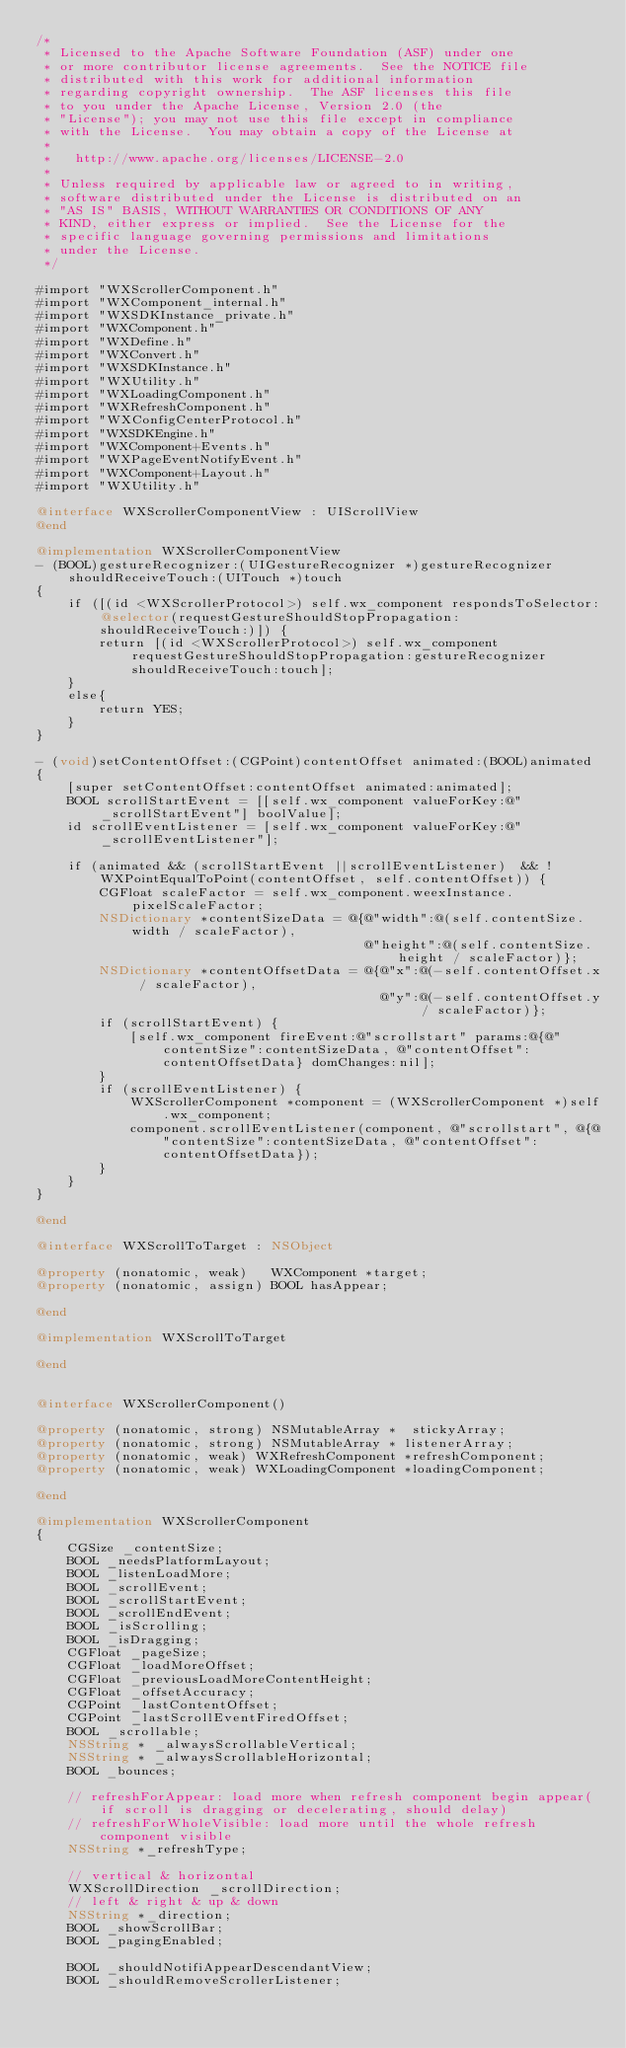Convert code to text. <code><loc_0><loc_0><loc_500><loc_500><_ObjectiveC_>/*
 * Licensed to the Apache Software Foundation (ASF) under one
 * or more contributor license agreements.  See the NOTICE file
 * distributed with this work for additional information
 * regarding copyright ownership.  The ASF licenses this file
 * to you under the Apache License, Version 2.0 (the
 * "License"); you may not use this file except in compliance
 * with the License.  You may obtain a copy of the License at
 *
 *   http://www.apache.org/licenses/LICENSE-2.0
 *
 * Unless required by applicable law or agreed to in writing,
 * software distributed under the License is distributed on an
 * "AS IS" BASIS, WITHOUT WARRANTIES OR CONDITIONS OF ANY
 * KIND, either express or implied.  See the License for the
 * specific language governing permissions and limitations
 * under the License.
 */

#import "WXScrollerComponent.h"
#import "WXComponent_internal.h"
#import "WXSDKInstance_private.h"
#import "WXComponent.h"
#import "WXDefine.h"
#import "WXConvert.h"
#import "WXSDKInstance.h"
#import "WXUtility.h"
#import "WXLoadingComponent.h"
#import "WXRefreshComponent.h"
#import "WXConfigCenterProtocol.h"
#import "WXSDKEngine.h"
#import "WXComponent+Events.h"
#import "WXPageEventNotifyEvent.h"
#import "WXComponent+Layout.h"
#import "WXUtility.h"

@interface WXScrollerComponentView : UIScrollView
@end

@implementation WXScrollerComponentView
- (BOOL)gestureRecognizer:(UIGestureRecognizer *)gestureRecognizer shouldReceiveTouch:(UITouch *)touch
{
    if ([(id <WXScrollerProtocol>) self.wx_component respondsToSelector:@selector(requestGestureShouldStopPropagation:shouldReceiveTouch:)]) {
        return [(id <WXScrollerProtocol>) self.wx_component requestGestureShouldStopPropagation:gestureRecognizer shouldReceiveTouch:touch];
    }
    else{
        return YES;
    }
}

- (void)setContentOffset:(CGPoint)contentOffset animated:(BOOL)animated
{
    [super setContentOffset:contentOffset animated:animated];
    BOOL scrollStartEvent = [[self.wx_component valueForKey:@"_scrollStartEvent"] boolValue];
    id scrollEventListener = [self.wx_component valueForKey:@"_scrollEventListener"];
    
    if (animated && (scrollStartEvent ||scrollEventListener)  && !WXPointEqualToPoint(contentOffset, self.contentOffset)) {
        CGFloat scaleFactor = self.wx_component.weexInstance.pixelScaleFactor;
        NSDictionary *contentSizeData = @{@"width":@(self.contentSize.width / scaleFactor),
                                          @"height":@(self.contentSize.height / scaleFactor)};
        NSDictionary *contentOffsetData = @{@"x":@(-self.contentOffset.x / scaleFactor),
                                            @"y":@(-self.contentOffset.y / scaleFactor)};
        if (scrollStartEvent) {
            [self.wx_component fireEvent:@"scrollstart" params:@{@"contentSize":contentSizeData, @"contentOffset":contentOffsetData} domChanges:nil];
        }
        if (scrollEventListener) {
            WXScrollerComponent *component = (WXScrollerComponent *)self.wx_component;
            component.scrollEventListener(component, @"scrollstart", @{@"contentSize":contentSizeData, @"contentOffset":contentOffsetData});
        }
    }
}

@end

@interface WXScrollToTarget : NSObject

@property (nonatomic, weak)   WXComponent *target;
@property (nonatomic, assign) BOOL hasAppear;

@end

@implementation WXScrollToTarget

@end


@interface WXScrollerComponent()

@property (nonatomic, strong) NSMutableArray *  stickyArray;
@property (nonatomic, strong) NSMutableArray * listenerArray;
@property (nonatomic, weak) WXRefreshComponent *refreshComponent;
@property (nonatomic, weak) WXLoadingComponent *loadingComponent;

@end

@implementation WXScrollerComponent
{
    CGSize _contentSize;
    BOOL _needsPlatformLayout;
    BOOL _listenLoadMore;
    BOOL _scrollEvent;
    BOOL _scrollStartEvent;
    BOOL _scrollEndEvent;
    BOOL _isScrolling;
    BOOL _isDragging;
    CGFloat _pageSize;
    CGFloat _loadMoreOffset;
    CGFloat _previousLoadMoreContentHeight;
    CGFloat _offsetAccuracy;
    CGPoint _lastContentOffset;
    CGPoint _lastScrollEventFiredOffset;
    BOOL _scrollable;
    NSString * _alwaysScrollableVertical;
    NSString * _alwaysScrollableHorizontal;
    BOOL _bounces;
    
    // refreshForAppear: load more when refresh component begin appear(if scroll is dragging or decelerating, should delay)
    // refreshForWholeVisible: load more until the whole refresh component visible
    NSString *_refreshType;

    // vertical & horizontal
    WXScrollDirection _scrollDirection;
    // left & right & up & down
    NSString *_direction;
    BOOL _showScrollBar;
    BOOL _pagingEnabled;
    
    BOOL _shouldNotifiAppearDescendantView;
    BOOL _shouldRemoveScrollerListener;</code> 